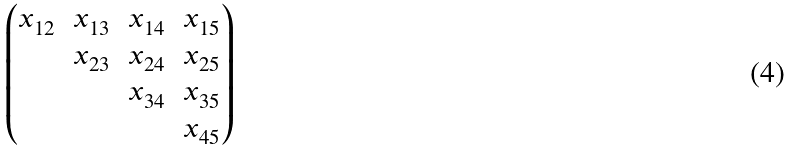<formula> <loc_0><loc_0><loc_500><loc_500>\begin{pmatrix} x _ { 1 2 } & x _ { 1 3 } & x _ { 1 4 } & x _ { 1 5 } \\ & x _ { 2 3 } & x _ { 2 4 } & x _ { 2 5 } \\ & & x _ { 3 4 } & x _ { 3 5 } \\ & & & x _ { 4 5 } \\ \end{pmatrix}</formula> 